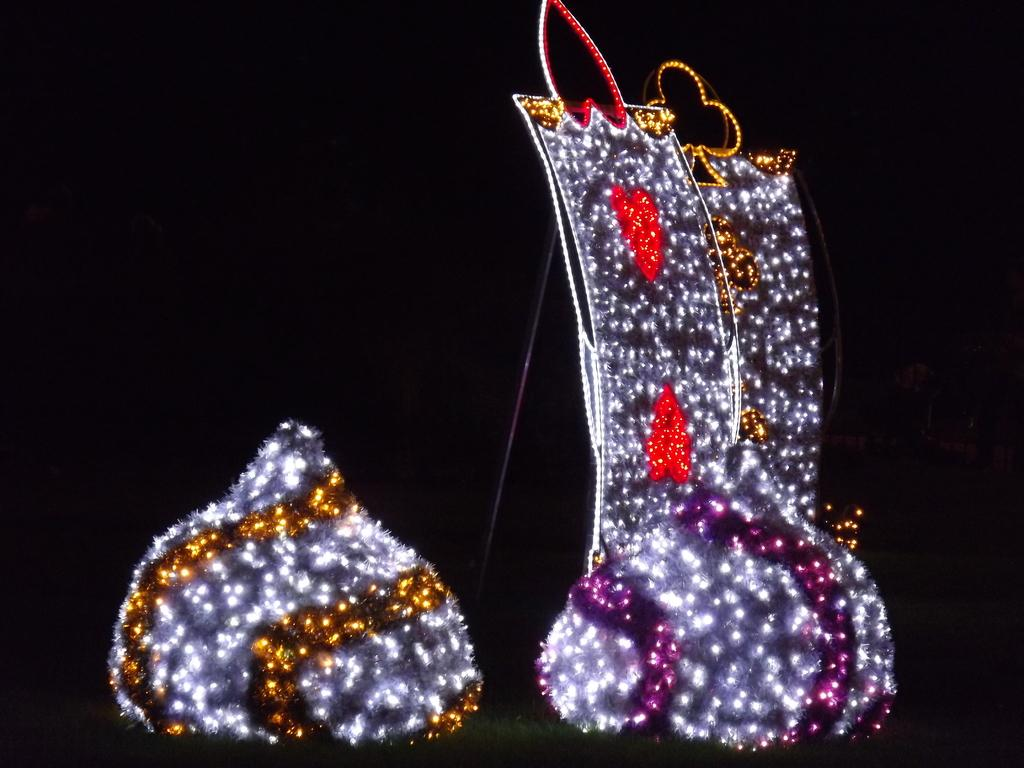What can be seen on the right side of the image? There are lights arranged in different forms on the right side of the image. What shape do the lights on the left side of the image form? The lights on the left side of the image are arranged in a turnip shape. What reward is being given to the students in the image? There is no mention of students or rewards in the image; it only features lights arranged in different forms and a turnip shape. 